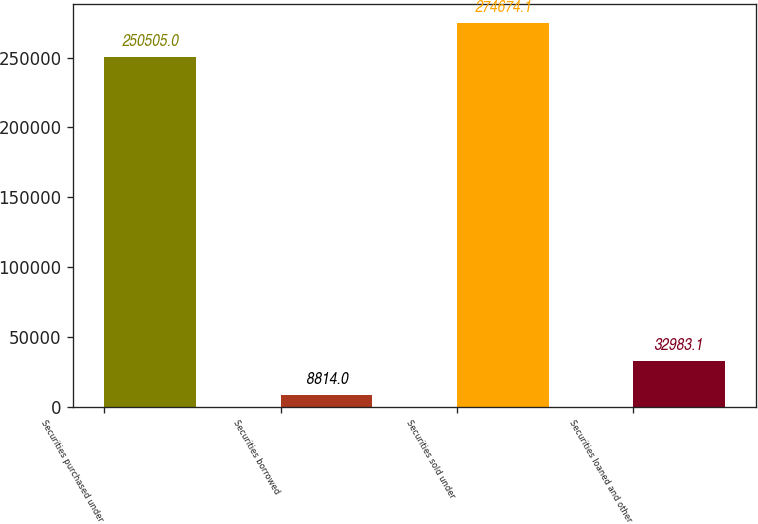Convert chart to OTSL. <chart><loc_0><loc_0><loc_500><loc_500><bar_chart><fcel>Securities purchased under<fcel>Securities borrowed<fcel>Securities sold under<fcel>Securities loaned and other<nl><fcel>250505<fcel>8814<fcel>274674<fcel>32983.1<nl></chart> 